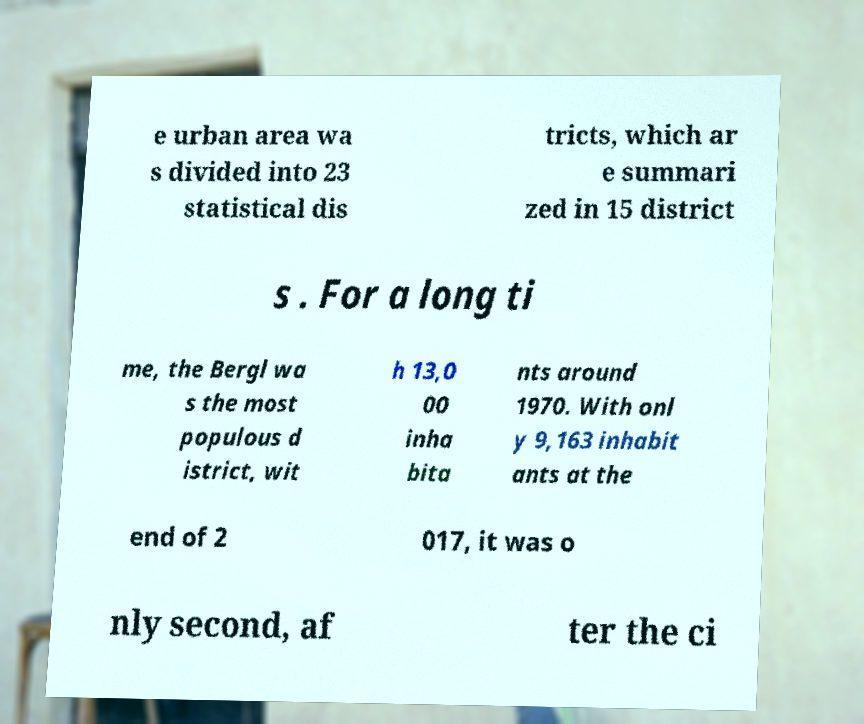Can you accurately transcribe the text from the provided image for me? e urban area wa s divided into 23 statistical dis tricts, which ar e summari zed in 15 district s . For a long ti me, the Bergl wa s the most populous d istrict, wit h 13,0 00 inha bita nts around 1970. With onl y 9,163 inhabit ants at the end of 2 017, it was o nly second, af ter the ci 